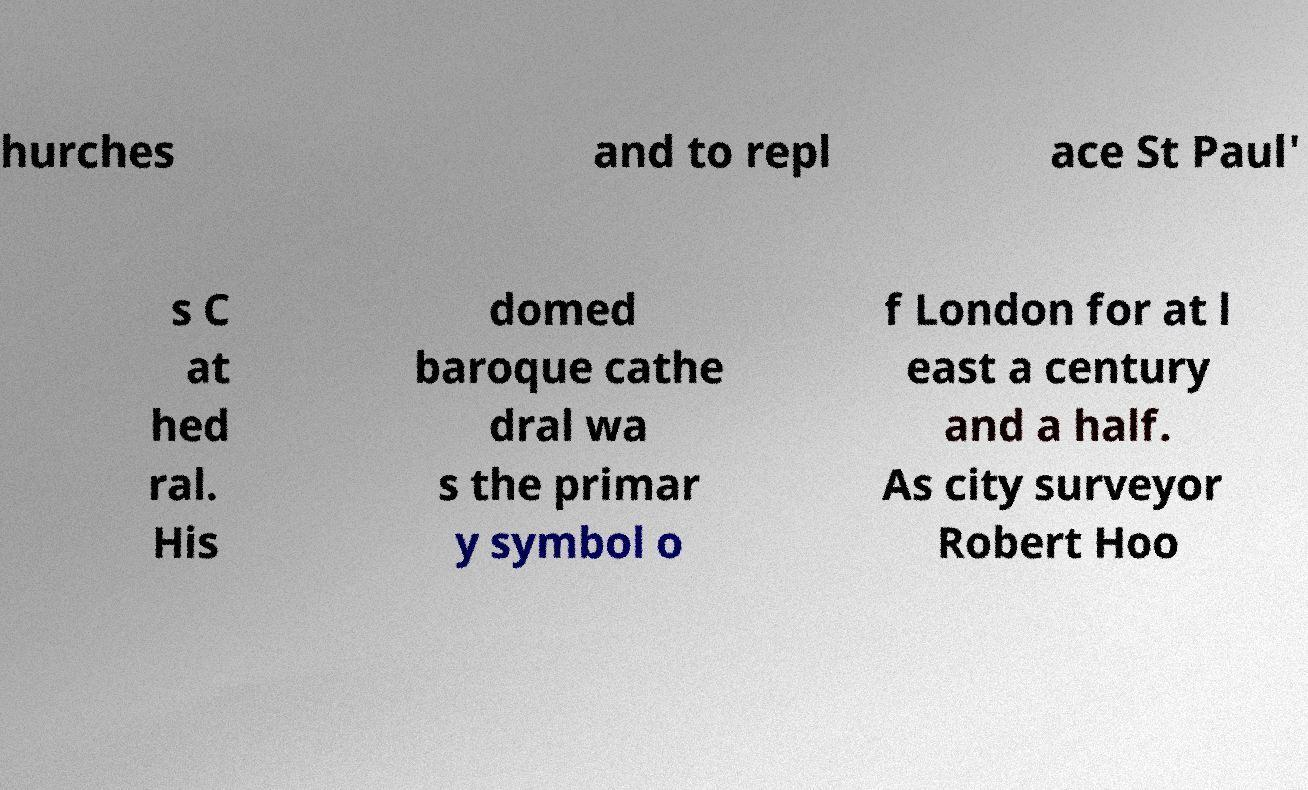Please identify and transcribe the text found in this image. hurches and to repl ace St Paul' s C at hed ral. His domed baroque cathe dral wa s the primar y symbol o f London for at l east a century and a half. As city surveyor Robert Hoo 